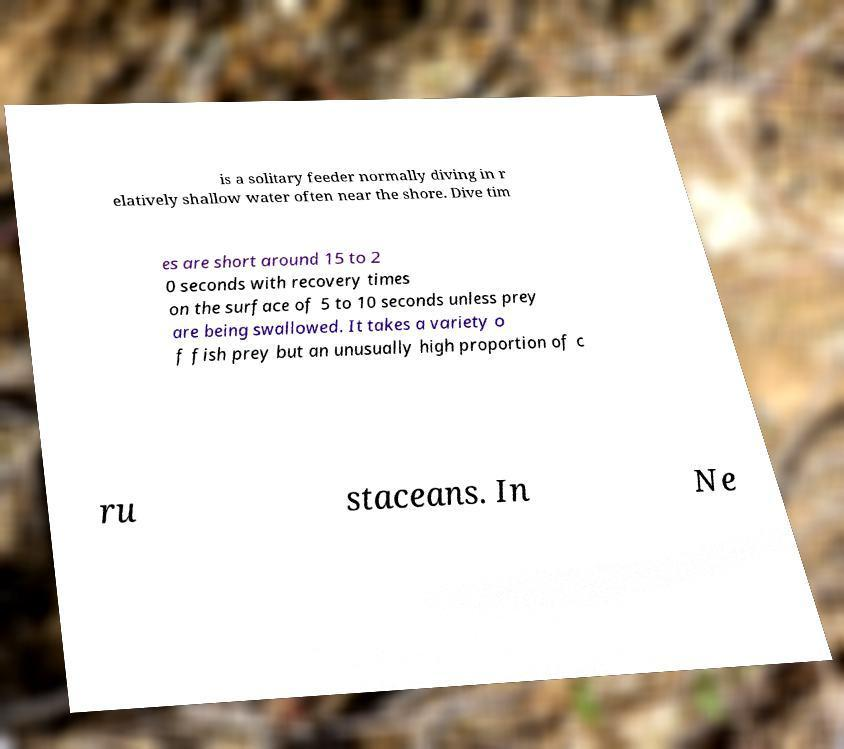Can you read and provide the text displayed in the image?This photo seems to have some interesting text. Can you extract and type it out for me? is a solitary feeder normally diving in r elatively shallow water often near the shore. Dive tim es are short around 15 to 2 0 seconds with recovery times on the surface of 5 to 10 seconds unless prey are being swallowed. It takes a variety o f fish prey but an unusually high proportion of c ru staceans. In Ne 